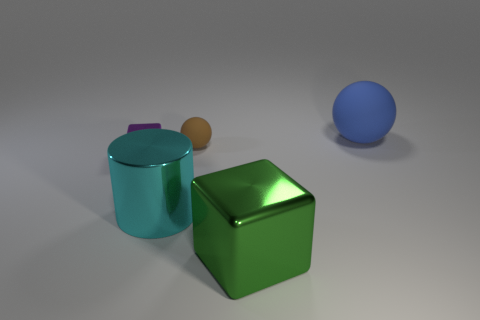There is a shiny thing on the right side of the tiny thing that is behind the metal cube that is behind the cyan shiny object; what is its shape?
Provide a short and direct response. Cube. How many yellow things are either matte balls or small things?
Provide a short and direct response. 0. Are there the same number of small brown balls to the left of the large cyan object and big shiny things that are to the right of the green metallic cube?
Your answer should be very brief. Yes. There is a object that is on the right side of the big green shiny block; is its shape the same as the tiny thing that is behind the tiny purple cube?
Provide a short and direct response. Yes. Is there any other thing that has the same shape as the cyan thing?
Make the answer very short. No. What is the shape of the other large object that is made of the same material as the large cyan object?
Offer a very short reply. Cube. Are there the same number of large green blocks that are behind the purple object and green matte cylinders?
Provide a short and direct response. Yes. Is the sphere that is in front of the large blue object made of the same material as the large object behind the large cylinder?
Keep it short and to the point. Yes. What shape is the small object that is in front of the tiny brown rubber ball behind the green shiny cube?
Ensure brevity in your answer.  Cube. What is the color of the cylinder that is made of the same material as the big green block?
Provide a short and direct response. Cyan. 